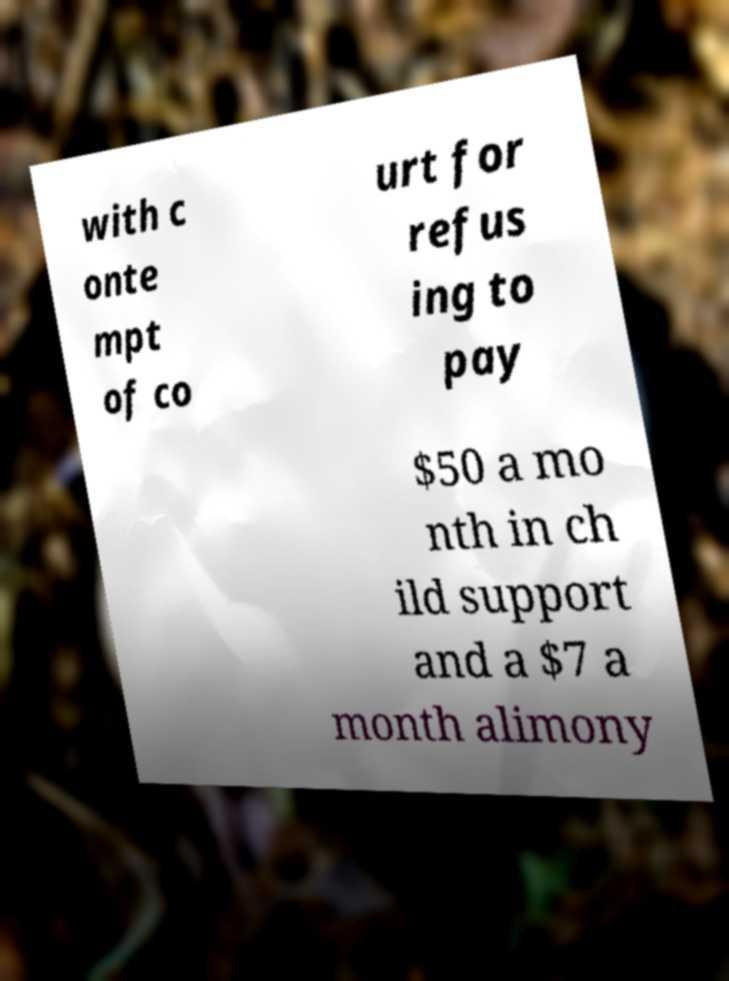Can you accurately transcribe the text from the provided image for me? with c onte mpt of co urt for refus ing to pay $50 a mo nth in ch ild support and a $7 a month alimony 